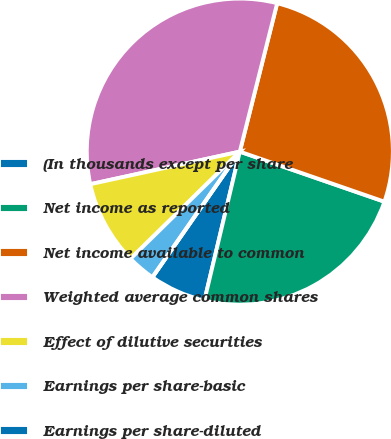Convert chart. <chart><loc_0><loc_0><loc_500><loc_500><pie_chart><fcel>(In thousands except per share<fcel>Net income as reported<fcel>Net income available to common<fcel>Weighted average common shares<fcel>Effect of dilutive securities<fcel>Earnings per share-basic<fcel>Earnings per share-diluted<nl><fcel>5.96%<fcel>23.41%<fcel>26.38%<fcel>32.34%<fcel>8.93%<fcel>2.98%<fcel>0.0%<nl></chart> 